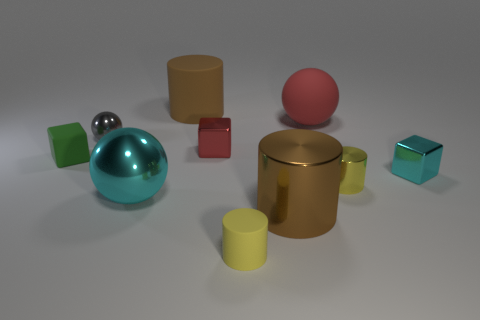The gray object is what size?
Provide a succinct answer. Small. Are there any brown cylinders that have the same material as the tiny green object?
Your answer should be very brief. Yes. The green matte object that is the same shape as the red metallic object is what size?
Keep it short and to the point. Small. Are there the same number of red things that are behind the red shiny thing and yellow metal cylinders?
Offer a terse response. Yes. Do the cyan object that is behind the large cyan metallic object and the small green matte object have the same shape?
Ensure brevity in your answer.  Yes. What shape is the large cyan shiny thing?
Offer a terse response. Sphere. There is a big ball that is on the right side of the brown cylinder behind the red object on the left side of the red sphere; what is its material?
Your answer should be very brief. Rubber. What is the material of the thing that is the same color as the large rubber ball?
Offer a very short reply. Metal. What number of things are small gray spheres or tiny gray blocks?
Your response must be concise. 1. Is the tiny yellow cylinder that is right of the red rubber sphere made of the same material as the big cyan sphere?
Offer a terse response. Yes. 